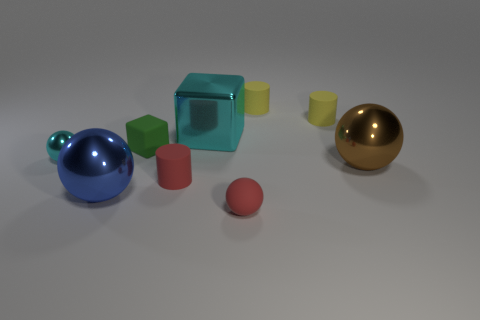Are there any metal objects that are on the right side of the blue thing that is left of the green matte block?
Make the answer very short. Yes. Is the color of the small ball that is on the right side of the cyan block the same as the small matte cylinder that is in front of the small cyan object?
Keep it short and to the point. Yes. What number of blue balls are the same size as the green rubber block?
Provide a succinct answer. 0. There is a cylinder that is in front of the brown metallic sphere; is it the same size as the matte sphere?
Your answer should be very brief. Yes. What is the shape of the large blue metal thing?
Give a very brief answer. Sphere. What size is the block that is the same color as the tiny metal ball?
Offer a very short reply. Large. Is the material of the cyan object left of the big cyan block the same as the small green object?
Offer a very short reply. No. Are there any small rubber cylinders of the same color as the rubber sphere?
Your response must be concise. Yes. Does the cyan metallic object that is in front of the big cyan object have the same shape as the large object that is behind the small cyan ball?
Provide a succinct answer. No. Are there any other brown cubes made of the same material as the tiny cube?
Your answer should be very brief. No. 